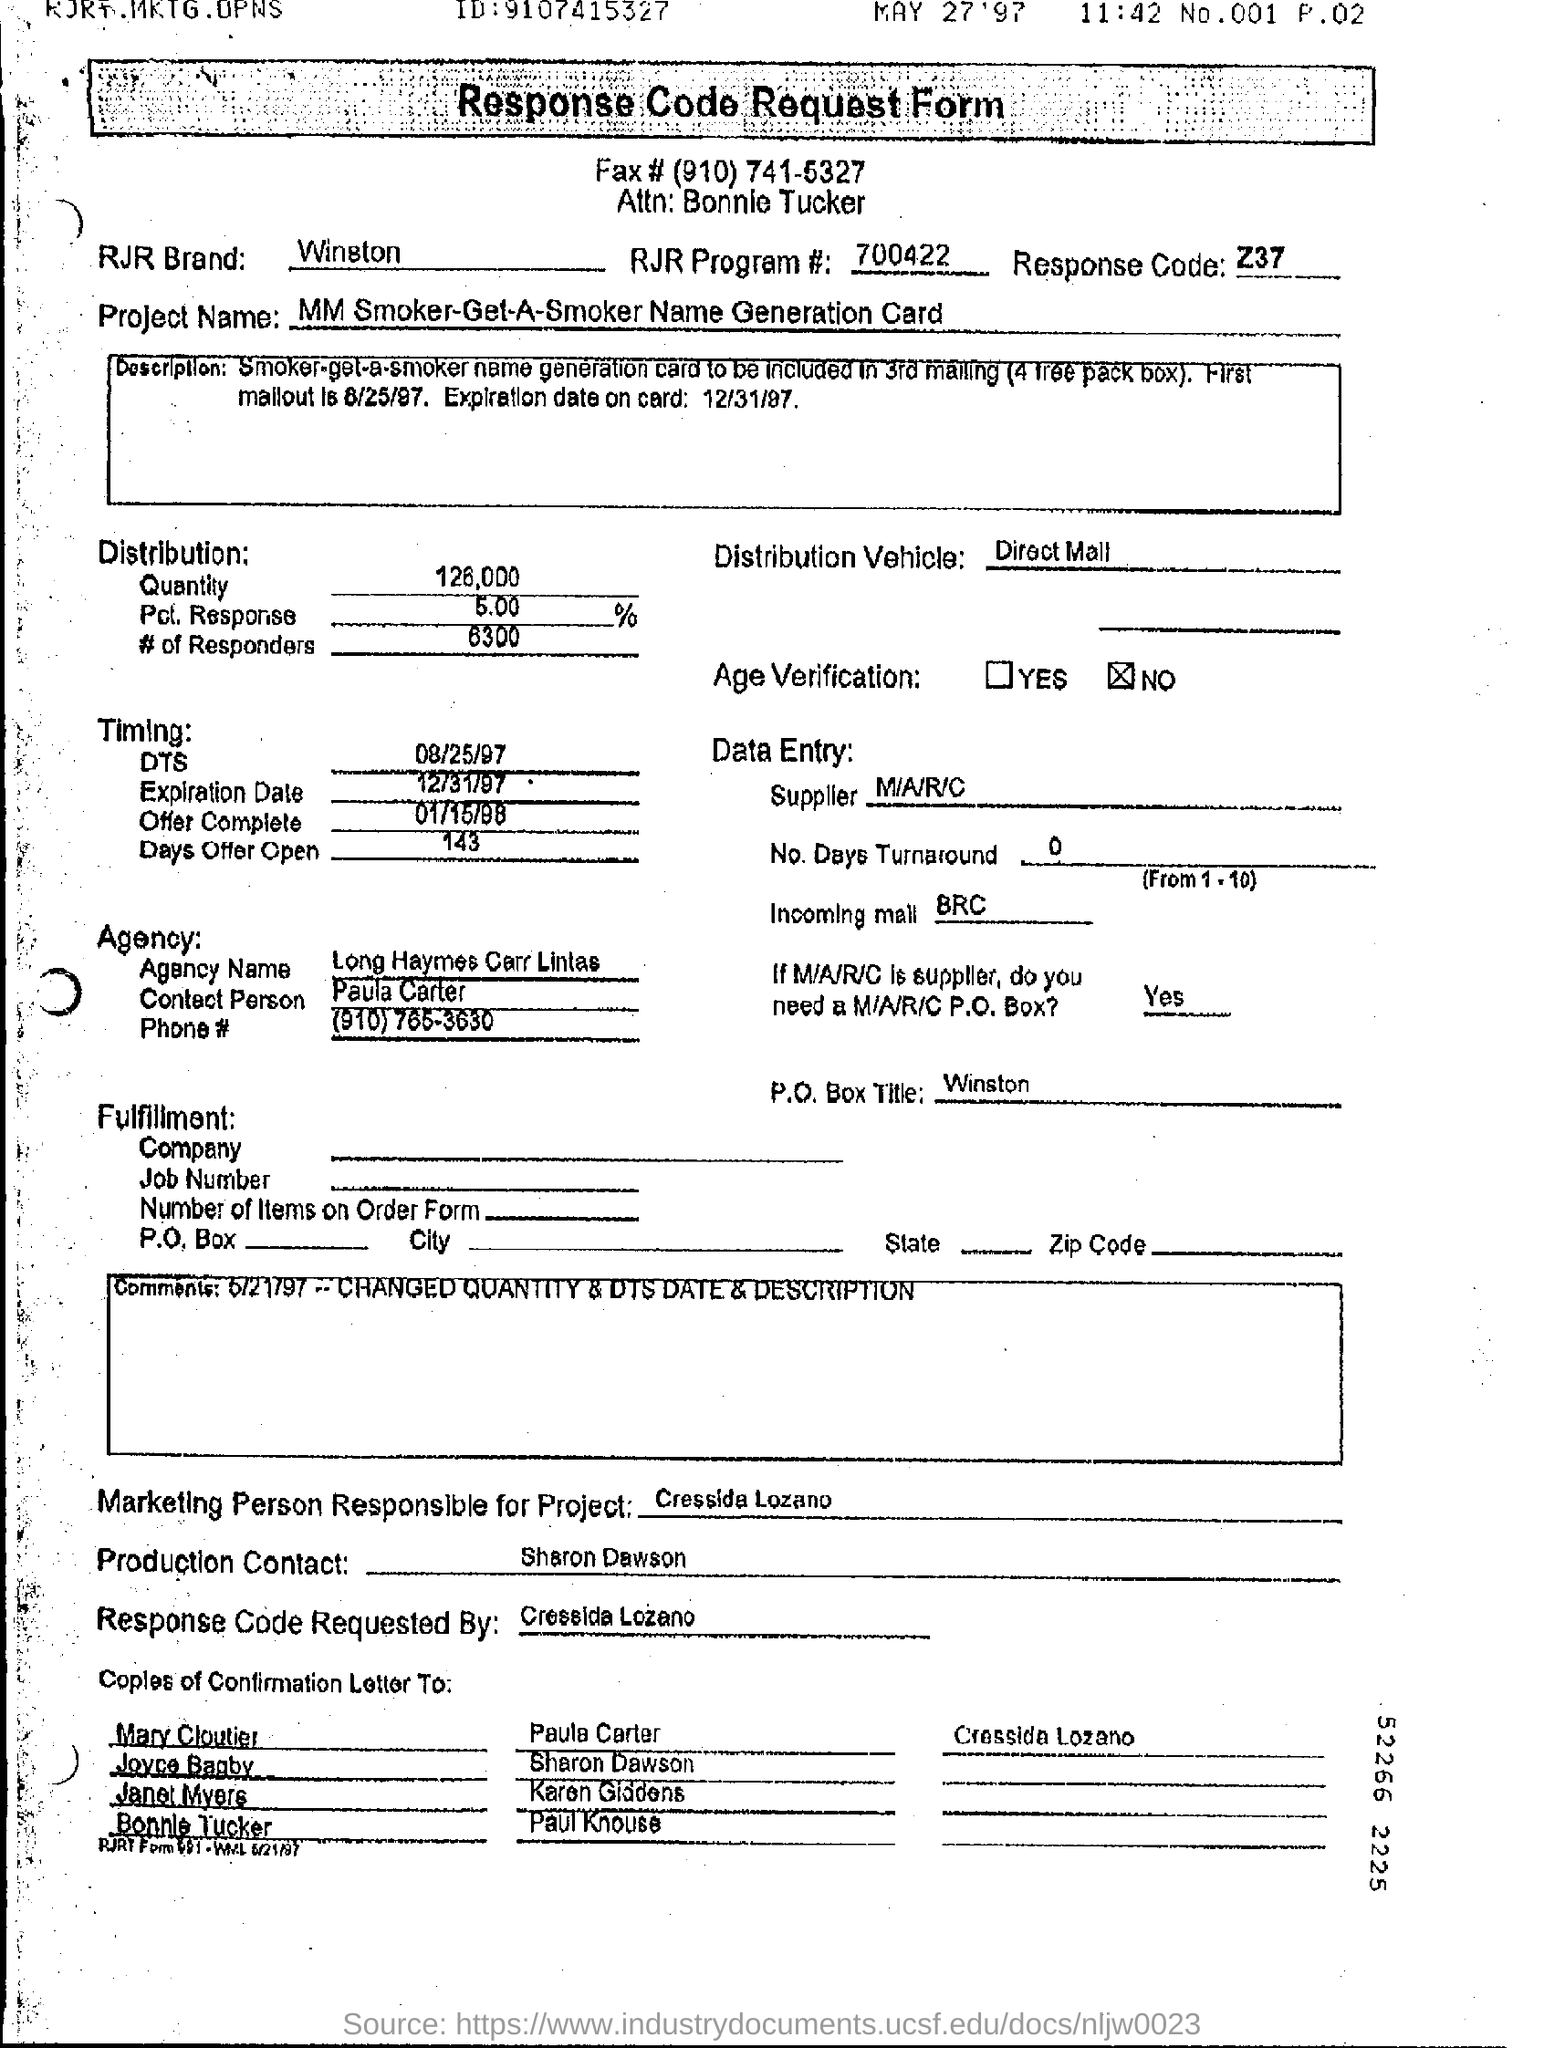On which date offer completes?
Your answer should be compact. 01/15/98. What is the name of the project?
Offer a very short reply. MM Smoker-Get-A-Smoker Name Generation Card. 